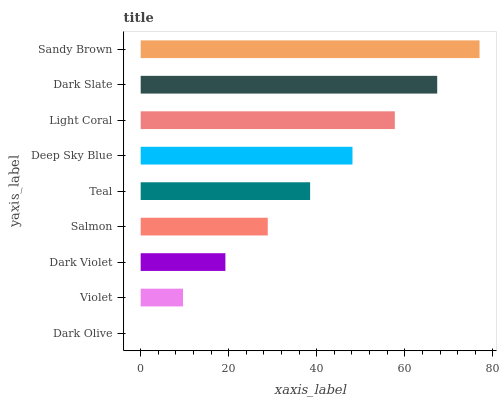Is Dark Olive the minimum?
Answer yes or no. Yes. Is Sandy Brown the maximum?
Answer yes or no. Yes. Is Violet the minimum?
Answer yes or no. No. Is Violet the maximum?
Answer yes or no. No. Is Violet greater than Dark Olive?
Answer yes or no. Yes. Is Dark Olive less than Violet?
Answer yes or no. Yes. Is Dark Olive greater than Violet?
Answer yes or no. No. Is Violet less than Dark Olive?
Answer yes or no. No. Is Teal the high median?
Answer yes or no. Yes. Is Teal the low median?
Answer yes or no. Yes. Is Salmon the high median?
Answer yes or no. No. Is Sandy Brown the low median?
Answer yes or no. No. 